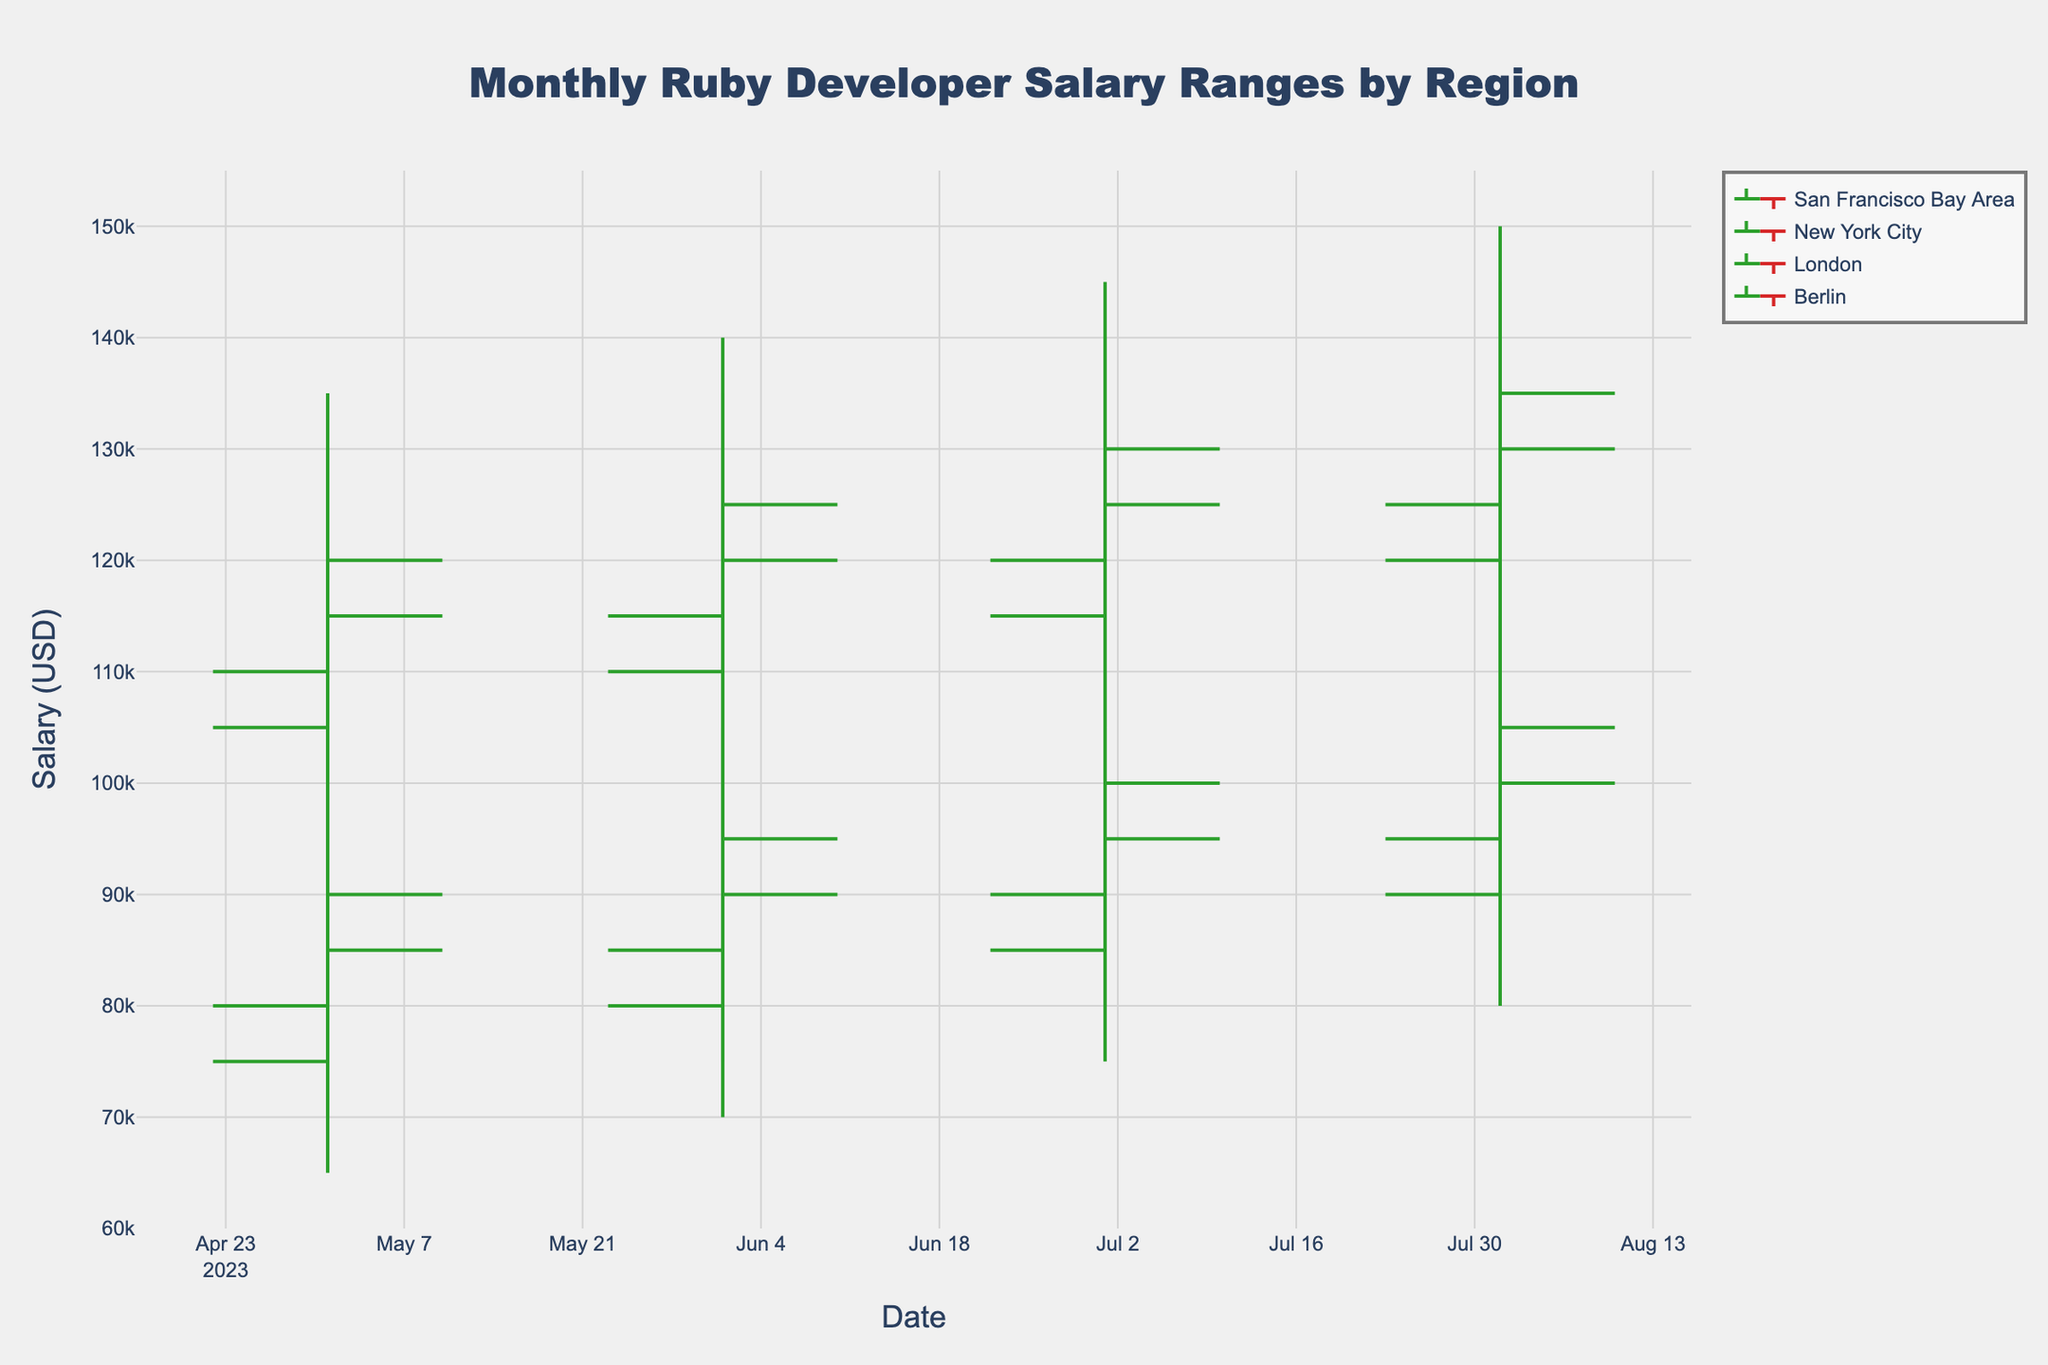What's the title of the figure? The title is displayed at the top of the figure and includes the text "Monthly Ruby Developer Salary Ranges by Region".
Answer: Monthly Ruby Developer Salary Ranges by Region What are the x-axis and y-axis titles? The x-axis title is displayed horizontally at the bottom and reads "Date". The y-axis title is displayed vertically on the left and reads "Salary (USD)".
Answer: Date; Salary (USD) Which region had the highest high salary in August 2023? Look for the highest peak (High value) in August 2023 across all regions. San Francisco Bay Area had the highest peak at $150,000.
Answer: San Francisco Bay Area Between which two consecutive months did the London region see the highest increase in closing salary? Compare the closing salaries of consecutive months for London. From May to June, the closing salary increased from $90,000 to $95,000 (+$5,000), but from June to July, it increased from $95,000 to $100,000 (+$5,000). Thus, the highest increase is from July to August where it increased from $100,000 to $105,000 (+$5,000).
Answer: July to August How many months of data are displayed in the figure? Count the different months on the x-axis, which range from May 2023 to August 2023.
Answer: 4 What is the lowest Low value recorded for Berlin and in which month did it occur? Look for the lowest point for Berlin in the figure. The lowest Low was $65,000 in May 2023.
Answer: $65,000 in May 2023 Which region showed a consistent increase in closing salary over the months displayed? To identify a consistent increase, check if the closing salaries for each month form an increasing sequence for each region. San Francisco Bay Area shows closing values of $120,000, $125,000, $130,000, and $135,000 from May to August respectively.
Answer: San Francisco Bay Area Which month had the widest salary range for New York City? Calculate the differences between the High and Low values for each month for New York City. The widest range is seen in August 2023, with a difference of $40,000 ($145,000 - $105,000).
Answer: August 2023 In which region and month did the highest closing salary occur? Find the highest closing salary for each region and month. The highest is $135,000 in August 2023 for the San Francisco Bay Area.
Answer: San Francisco Bay Area in August 2023 